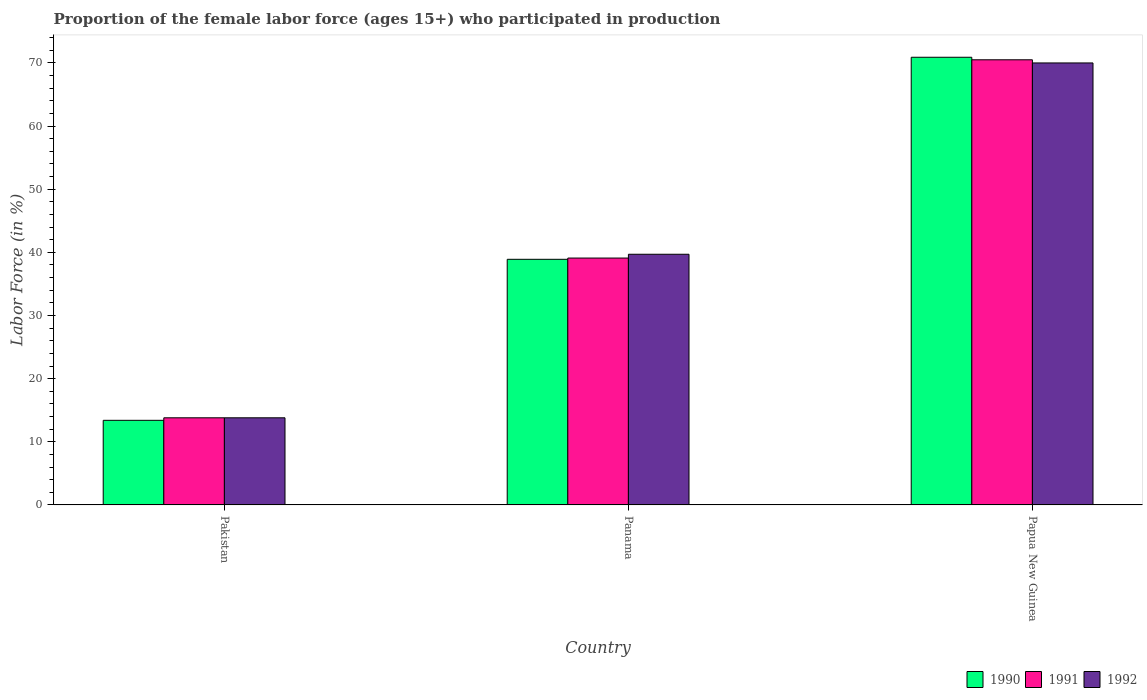How many groups of bars are there?
Provide a succinct answer. 3. Are the number of bars per tick equal to the number of legend labels?
Ensure brevity in your answer.  Yes. Are the number of bars on each tick of the X-axis equal?
Keep it short and to the point. Yes. What is the label of the 3rd group of bars from the left?
Keep it short and to the point. Papua New Guinea. In how many cases, is the number of bars for a given country not equal to the number of legend labels?
Your answer should be compact. 0. What is the proportion of the female labor force who participated in production in 1992 in Pakistan?
Provide a succinct answer. 13.8. Across all countries, what is the maximum proportion of the female labor force who participated in production in 1990?
Your answer should be very brief. 70.9. Across all countries, what is the minimum proportion of the female labor force who participated in production in 1990?
Keep it short and to the point. 13.4. In which country was the proportion of the female labor force who participated in production in 1992 maximum?
Your response must be concise. Papua New Guinea. In which country was the proportion of the female labor force who participated in production in 1992 minimum?
Give a very brief answer. Pakistan. What is the total proportion of the female labor force who participated in production in 1992 in the graph?
Your response must be concise. 123.5. What is the difference between the proportion of the female labor force who participated in production in 1990 in Pakistan and that in Panama?
Provide a succinct answer. -25.5. What is the difference between the proportion of the female labor force who participated in production in 1991 in Papua New Guinea and the proportion of the female labor force who participated in production in 1990 in Pakistan?
Provide a succinct answer. 57.1. What is the average proportion of the female labor force who participated in production in 1991 per country?
Offer a very short reply. 41.13. What is the difference between the proportion of the female labor force who participated in production of/in 1990 and proportion of the female labor force who participated in production of/in 1992 in Pakistan?
Your response must be concise. -0.4. In how many countries, is the proportion of the female labor force who participated in production in 1992 greater than 32 %?
Offer a very short reply. 2. What is the ratio of the proportion of the female labor force who participated in production in 1991 in Pakistan to that in Papua New Guinea?
Keep it short and to the point. 0.2. Is the difference between the proportion of the female labor force who participated in production in 1990 in Panama and Papua New Guinea greater than the difference between the proportion of the female labor force who participated in production in 1992 in Panama and Papua New Guinea?
Your response must be concise. No. What is the difference between the highest and the second highest proportion of the female labor force who participated in production in 1991?
Your answer should be compact. -56.7. What is the difference between the highest and the lowest proportion of the female labor force who participated in production in 1991?
Make the answer very short. 56.7. Is the sum of the proportion of the female labor force who participated in production in 1992 in Pakistan and Panama greater than the maximum proportion of the female labor force who participated in production in 1990 across all countries?
Give a very brief answer. No. What does the 1st bar from the left in Papua New Guinea represents?
Ensure brevity in your answer.  1990. What does the 2nd bar from the right in Papua New Guinea represents?
Provide a succinct answer. 1991. Is it the case that in every country, the sum of the proportion of the female labor force who participated in production in 1991 and proportion of the female labor force who participated in production in 1992 is greater than the proportion of the female labor force who participated in production in 1990?
Your answer should be compact. Yes. Are all the bars in the graph horizontal?
Offer a terse response. No. Does the graph contain grids?
Your answer should be very brief. No. How many legend labels are there?
Keep it short and to the point. 3. How are the legend labels stacked?
Provide a succinct answer. Horizontal. What is the title of the graph?
Make the answer very short. Proportion of the female labor force (ages 15+) who participated in production. Does "1977" appear as one of the legend labels in the graph?
Make the answer very short. No. What is the label or title of the X-axis?
Give a very brief answer. Country. What is the label or title of the Y-axis?
Offer a very short reply. Labor Force (in %). What is the Labor Force (in %) of 1990 in Pakistan?
Ensure brevity in your answer.  13.4. What is the Labor Force (in %) in 1991 in Pakistan?
Make the answer very short. 13.8. What is the Labor Force (in %) in 1992 in Pakistan?
Provide a succinct answer. 13.8. What is the Labor Force (in %) of 1990 in Panama?
Your answer should be compact. 38.9. What is the Labor Force (in %) in 1991 in Panama?
Your answer should be very brief. 39.1. What is the Labor Force (in %) in 1992 in Panama?
Make the answer very short. 39.7. What is the Labor Force (in %) in 1990 in Papua New Guinea?
Offer a very short reply. 70.9. What is the Labor Force (in %) of 1991 in Papua New Guinea?
Make the answer very short. 70.5. Across all countries, what is the maximum Labor Force (in %) in 1990?
Make the answer very short. 70.9. Across all countries, what is the maximum Labor Force (in %) of 1991?
Your answer should be very brief. 70.5. Across all countries, what is the maximum Labor Force (in %) in 1992?
Your answer should be very brief. 70. Across all countries, what is the minimum Labor Force (in %) in 1990?
Your answer should be compact. 13.4. Across all countries, what is the minimum Labor Force (in %) of 1991?
Make the answer very short. 13.8. Across all countries, what is the minimum Labor Force (in %) in 1992?
Offer a terse response. 13.8. What is the total Labor Force (in %) of 1990 in the graph?
Keep it short and to the point. 123.2. What is the total Labor Force (in %) in 1991 in the graph?
Your answer should be compact. 123.4. What is the total Labor Force (in %) in 1992 in the graph?
Offer a very short reply. 123.5. What is the difference between the Labor Force (in %) of 1990 in Pakistan and that in Panama?
Your response must be concise. -25.5. What is the difference between the Labor Force (in %) in 1991 in Pakistan and that in Panama?
Give a very brief answer. -25.3. What is the difference between the Labor Force (in %) in 1992 in Pakistan and that in Panama?
Provide a short and direct response. -25.9. What is the difference between the Labor Force (in %) of 1990 in Pakistan and that in Papua New Guinea?
Provide a short and direct response. -57.5. What is the difference between the Labor Force (in %) in 1991 in Pakistan and that in Papua New Guinea?
Offer a very short reply. -56.7. What is the difference between the Labor Force (in %) of 1992 in Pakistan and that in Papua New Guinea?
Ensure brevity in your answer.  -56.2. What is the difference between the Labor Force (in %) in 1990 in Panama and that in Papua New Guinea?
Keep it short and to the point. -32. What is the difference between the Labor Force (in %) of 1991 in Panama and that in Papua New Guinea?
Make the answer very short. -31.4. What is the difference between the Labor Force (in %) of 1992 in Panama and that in Papua New Guinea?
Your response must be concise. -30.3. What is the difference between the Labor Force (in %) of 1990 in Pakistan and the Labor Force (in %) of 1991 in Panama?
Keep it short and to the point. -25.7. What is the difference between the Labor Force (in %) of 1990 in Pakistan and the Labor Force (in %) of 1992 in Panama?
Ensure brevity in your answer.  -26.3. What is the difference between the Labor Force (in %) of 1991 in Pakistan and the Labor Force (in %) of 1992 in Panama?
Ensure brevity in your answer.  -25.9. What is the difference between the Labor Force (in %) in 1990 in Pakistan and the Labor Force (in %) in 1991 in Papua New Guinea?
Ensure brevity in your answer.  -57.1. What is the difference between the Labor Force (in %) in 1990 in Pakistan and the Labor Force (in %) in 1992 in Papua New Guinea?
Make the answer very short. -56.6. What is the difference between the Labor Force (in %) of 1991 in Pakistan and the Labor Force (in %) of 1992 in Papua New Guinea?
Give a very brief answer. -56.2. What is the difference between the Labor Force (in %) in 1990 in Panama and the Labor Force (in %) in 1991 in Papua New Guinea?
Offer a terse response. -31.6. What is the difference between the Labor Force (in %) of 1990 in Panama and the Labor Force (in %) of 1992 in Papua New Guinea?
Your answer should be compact. -31.1. What is the difference between the Labor Force (in %) of 1991 in Panama and the Labor Force (in %) of 1992 in Papua New Guinea?
Provide a short and direct response. -30.9. What is the average Labor Force (in %) in 1990 per country?
Your answer should be compact. 41.07. What is the average Labor Force (in %) in 1991 per country?
Provide a succinct answer. 41.13. What is the average Labor Force (in %) in 1992 per country?
Provide a succinct answer. 41.17. What is the difference between the Labor Force (in %) in 1990 and Labor Force (in %) in 1991 in Pakistan?
Your answer should be very brief. -0.4. What is the difference between the Labor Force (in %) of 1990 and Labor Force (in %) of 1991 in Panama?
Offer a very short reply. -0.2. What is the difference between the Labor Force (in %) of 1991 and Labor Force (in %) of 1992 in Panama?
Provide a short and direct response. -0.6. What is the difference between the Labor Force (in %) in 1990 and Labor Force (in %) in 1991 in Papua New Guinea?
Provide a short and direct response. 0.4. What is the difference between the Labor Force (in %) of 1990 and Labor Force (in %) of 1992 in Papua New Guinea?
Your answer should be very brief. 0.9. What is the ratio of the Labor Force (in %) in 1990 in Pakistan to that in Panama?
Offer a terse response. 0.34. What is the ratio of the Labor Force (in %) in 1991 in Pakistan to that in Panama?
Your answer should be very brief. 0.35. What is the ratio of the Labor Force (in %) of 1992 in Pakistan to that in Panama?
Offer a terse response. 0.35. What is the ratio of the Labor Force (in %) in 1990 in Pakistan to that in Papua New Guinea?
Keep it short and to the point. 0.19. What is the ratio of the Labor Force (in %) of 1991 in Pakistan to that in Papua New Guinea?
Make the answer very short. 0.2. What is the ratio of the Labor Force (in %) of 1992 in Pakistan to that in Papua New Guinea?
Give a very brief answer. 0.2. What is the ratio of the Labor Force (in %) of 1990 in Panama to that in Papua New Guinea?
Your answer should be compact. 0.55. What is the ratio of the Labor Force (in %) in 1991 in Panama to that in Papua New Guinea?
Offer a very short reply. 0.55. What is the ratio of the Labor Force (in %) of 1992 in Panama to that in Papua New Guinea?
Make the answer very short. 0.57. What is the difference between the highest and the second highest Labor Force (in %) in 1991?
Offer a terse response. 31.4. What is the difference between the highest and the second highest Labor Force (in %) of 1992?
Ensure brevity in your answer.  30.3. What is the difference between the highest and the lowest Labor Force (in %) of 1990?
Your answer should be compact. 57.5. What is the difference between the highest and the lowest Labor Force (in %) of 1991?
Offer a very short reply. 56.7. What is the difference between the highest and the lowest Labor Force (in %) in 1992?
Offer a terse response. 56.2. 